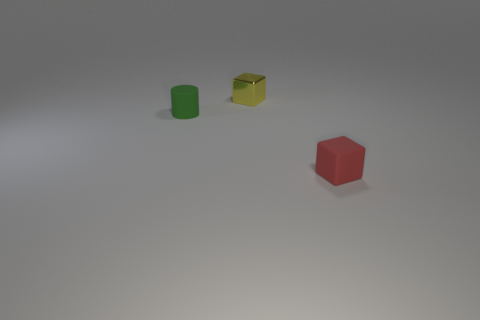How many small green matte cylinders are in front of the tiny cube that is to the left of the red cube? There is one small green matte cylinder positioned directly in front of the tiny yellow cube, which is situated to the left of the red cube. This scene is composed in a minimalistic style with ample space around each object, making the relationships between them clear and unambiguous. 